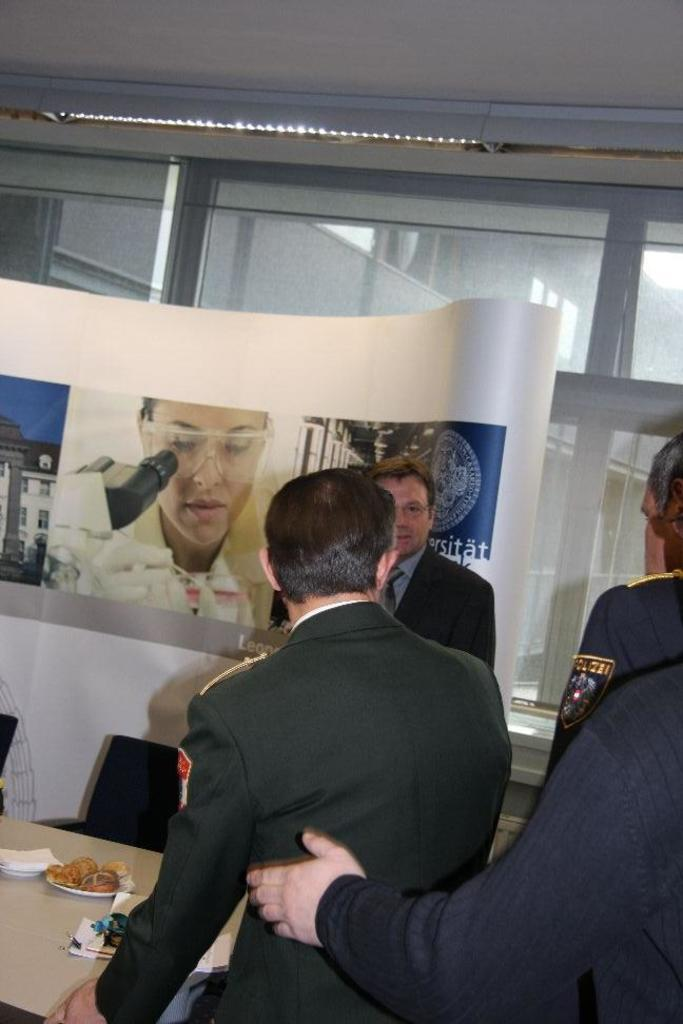How many people are in the image? There are persons standing in the image, but the exact number cannot be determined from the provided facts. What surface are the persons standing on? The persons are standing on the floor. What furniture is present in the image? There is a table and chairs in the image. What type of tableware is present in the image? There is a plate and paper napkins in the image. What type of food is visible in the image? There is food in the image, but the specific type cannot be determined from the provided facts. What additional objects can be seen in the image? There is an advertisement, doors, and electric lights in the image. What direction are the persons in the image facing? The direction the persons are facing cannot be determined from the provided facts. Is there a road visible in the image? There is no mention of a road in the provided facts, so it cannot be determined if one is present in the image. 